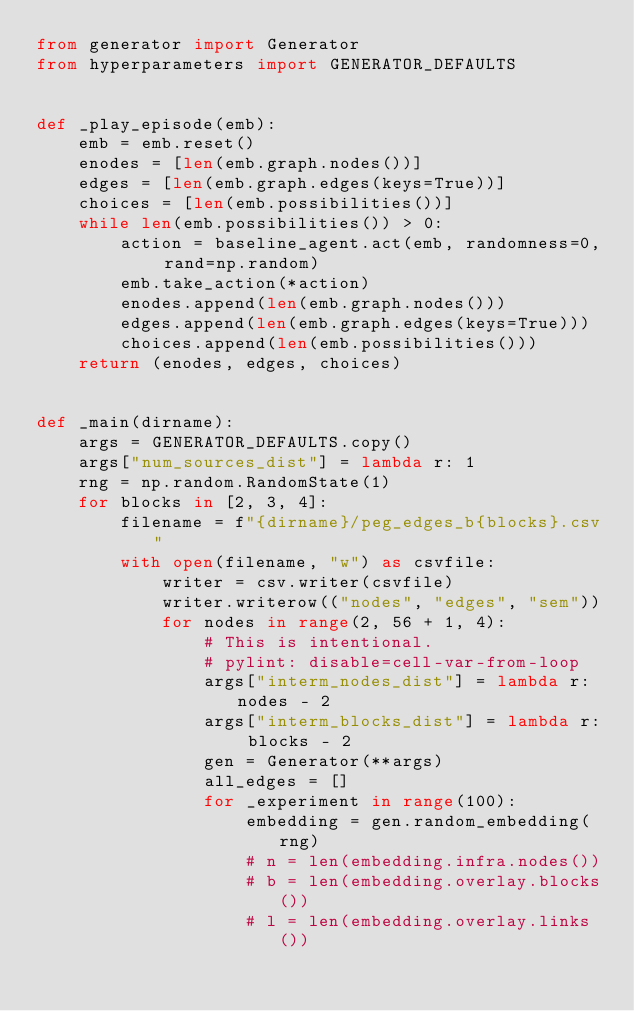Convert code to text. <code><loc_0><loc_0><loc_500><loc_500><_Python_>from generator import Generator
from hyperparameters import GENERATOR_DEFAULTS


def _play_episode(emb):
    emb = emb.reset()
    enodes = [len(emb.graph.nodes())]
    edges = [len(emb.graph.edges(keys=True))]
    choices = [len(emb.possibilities())]
    while len(emb.possibilities()) > 0:
        action = baseline_agent.act(emb, randomness=0, rand=np.random)
        emb.take_action(*action)
        enodes.append(len(emb.graph.nodes()))
        edges.append(len(emb.graph.edges(keys=True)))
        choices.append(len(emb.possibilities()))
    return (enodes, edges, choices)


def _main(dirname):
    args = GENERATOR_DEFAULTS.copy()
    args["num_sources_dist"] = lambda r: 1
    rng = np.random.RandomState(1)
    for blocks in [2, 3, 4]:
        filename = f"{dirname}/peg_edges_b{blocks}.csv"
        with open(filename, "w") as csvfile:
            writer = csv.writer(csvfile)
            writer.writerow(("nodes", "edges", "sem"))
            for nodes in range(2, 56 + 1, 4):
                # This is intentional.
                # pylint: disable=cell-var-from-loop
                args["interm_nodes_dist"] = lambda r: nodes - 2
                args["interm_blocks_dist"] = lambda r: blocks - 2
                gen = Generator(**args)
                all_edges = []
                for _experiment in range(100):
                    embedding = gen.random_embedding(rng)
                    # n = len(embedding.infra.nodes())
                    # b = len(embedding.overlay.blocks())
                    # l = len(embedding.overlay.links())</code> 